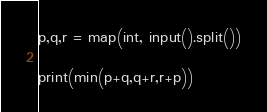<code> <loc_0><loc_0><loc_500><loc_500><_Python_>p,q,r = map(int, input().split())

print(min(p+q,q+r,r+p))</code> 